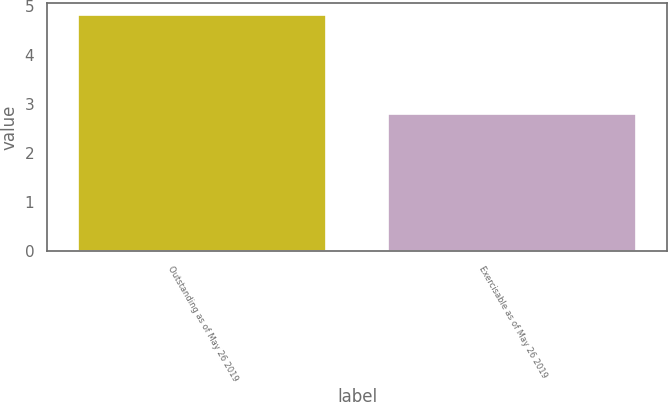<chart> <loc_0><loc_0><loc_500><loc_500><bar_chart><fcel>Outstanding as of May 26 2019<fcel>Exercisable as of May 26 2019<nl><fcel>4.82<fcel>2.79<nl></chart> 